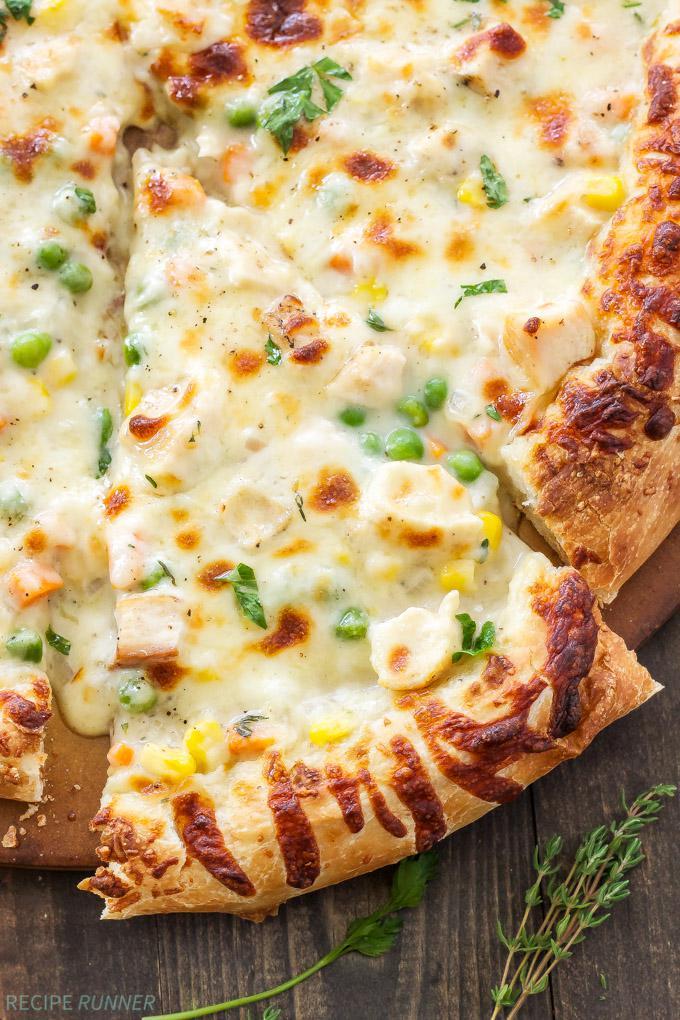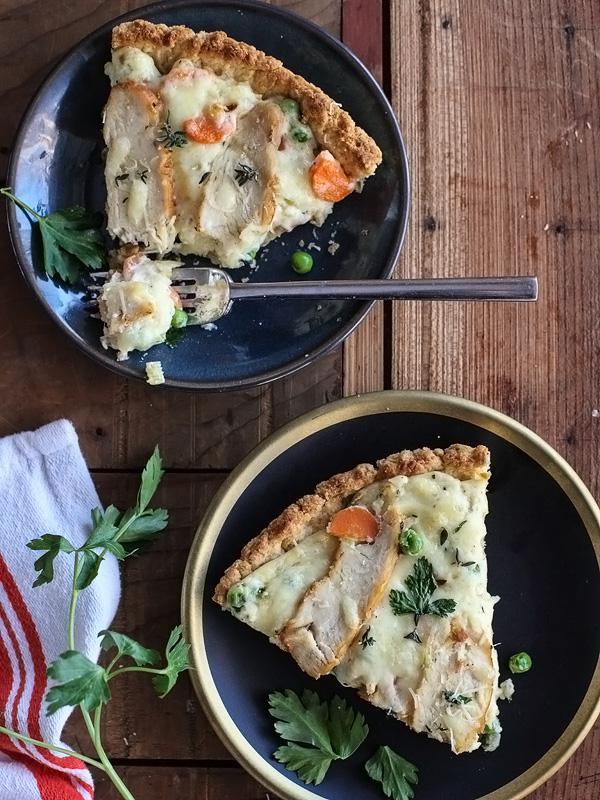The first image is the image on the left, the second image is the image on the right. Evaluate the accuracy of this statement regarding the images: "There are two circle pizza with only one slice missing.". Is it true? Answer yes or no. No. 